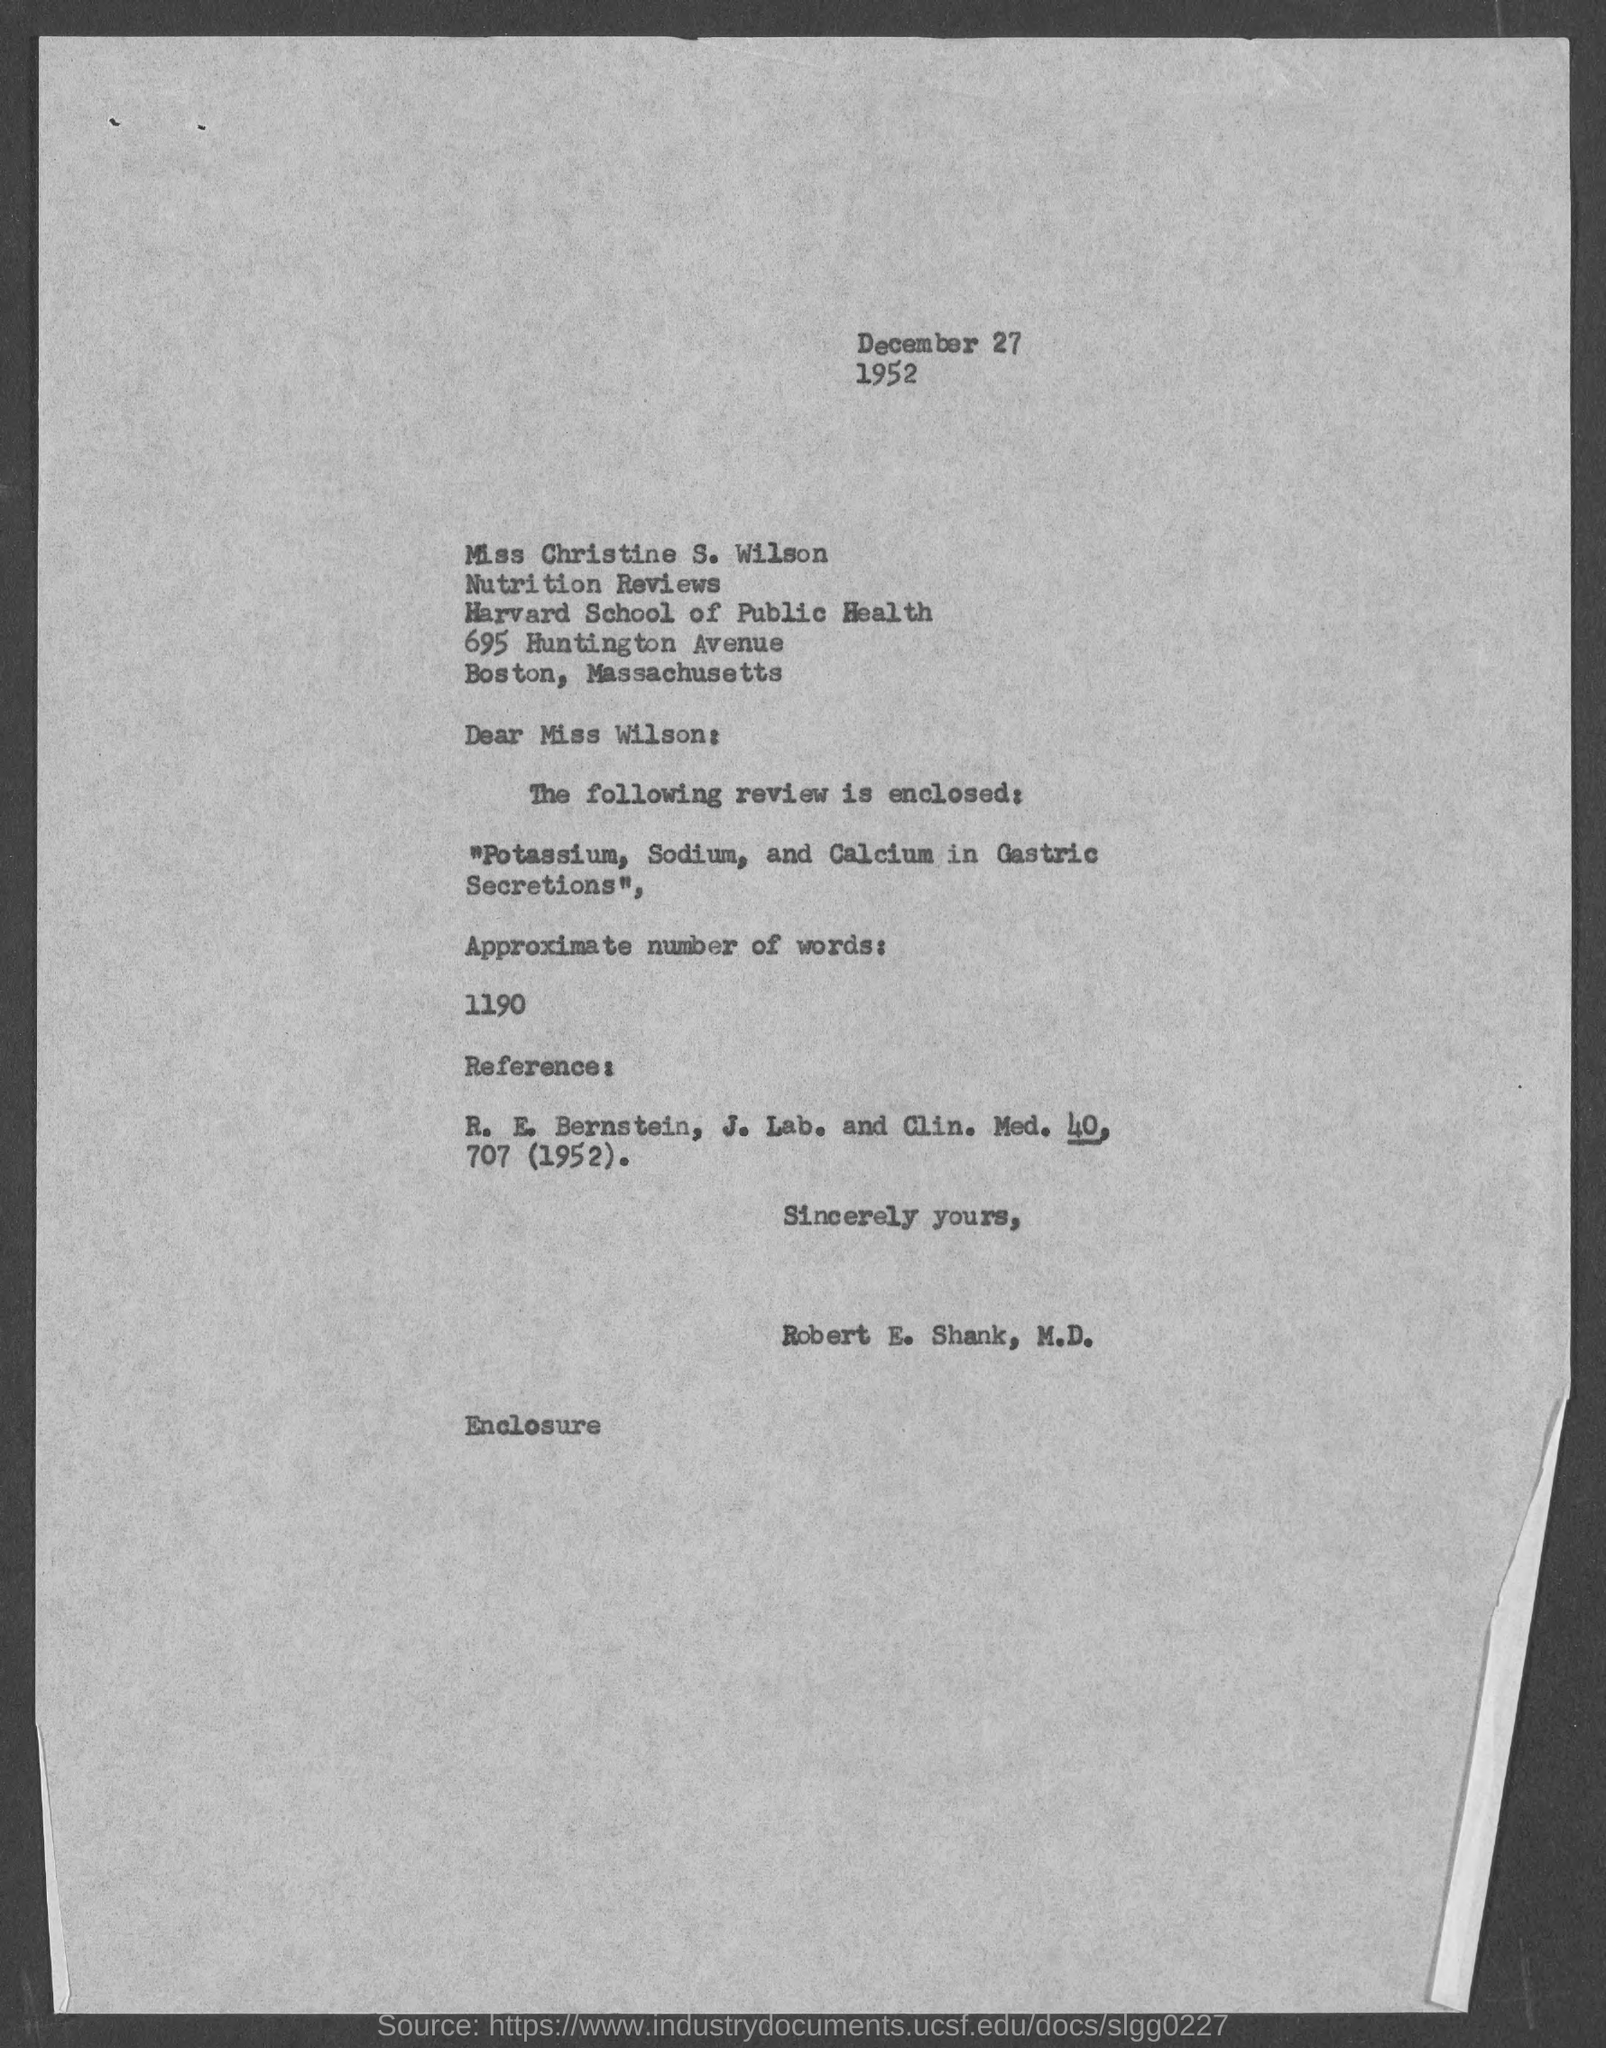Who is the Memorandum Address to ?
Make the answer very short. Miss Christine S. Wilson. 